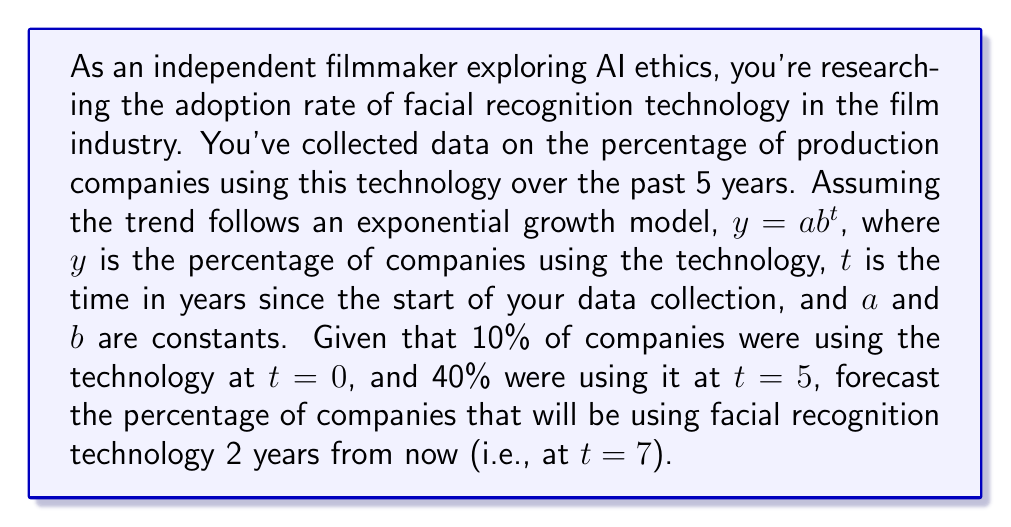Give your solution to this math problem. To solve this problem, we need to follow these steps:

1) We know that the model is $y = ab^t$, where $a$ is the initial value (at $t=0$) and $b$ is the growth factor.

2) We're given two data points:
   At $t=0$, $y = 10\%$ (or 0.10)
   At $t=5$, $y = 40\%$ (or 0.40)

3) Let's use these to set up two equations:
   $0.10 = a(b^0) = a$
   $0.40 = a(b^5)$

4) From the first equation, we know that $a = 0.10$

5) Substitute this into the second equation:
   $0.40 = 0.10(b^5)$

6) Solve for $b$:
   $4 = b^5$
   $b = \sqrt[5]{4} \approx 1.3195$

7) Now we have our full model:
   $y = 0.10(1.3195^t)$

8) To forecast for $t=7$, we simply plug this value into our model:
   $y = 0.10(1.3195^7) \approx 0.6971$

9) Convert to a percentage: $0.6971 \times 100\% \approx 69.71\%$
Answer: Approximately 69.71% of production companies are forecasted to be using facial recognition technology 7 years after the start of data collection. 